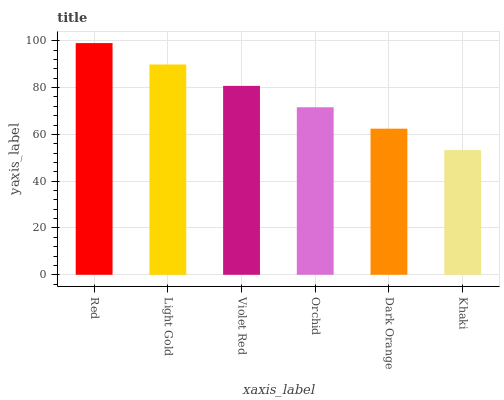Is Khaki the minimum?
Answer yes or no. Yes. Is Red the maximum?
Answer yes or no. Yes. Is Light Gold the minimum?
Answer yes or no. No. Is Light Gold the maximum?
Answer yes or no. No. Is Red greater than Light Gold?
Answer yes or no. Yes. Is Light Gold less than Red?
Answer yes or no. Yes. Is Light Gold greater than Red?
Answer yes or no. No. Is Red less than Light Gold?
Answer yes or no. No. Is Violet Red the high median?
Answer yes or no. Yes. Is Orchid the low median?
Answer yes or no. Yes. Is Khaki the high median?
Answer yes or no. No. Is Dark Orange the low median?
Answer yes or no. No. 